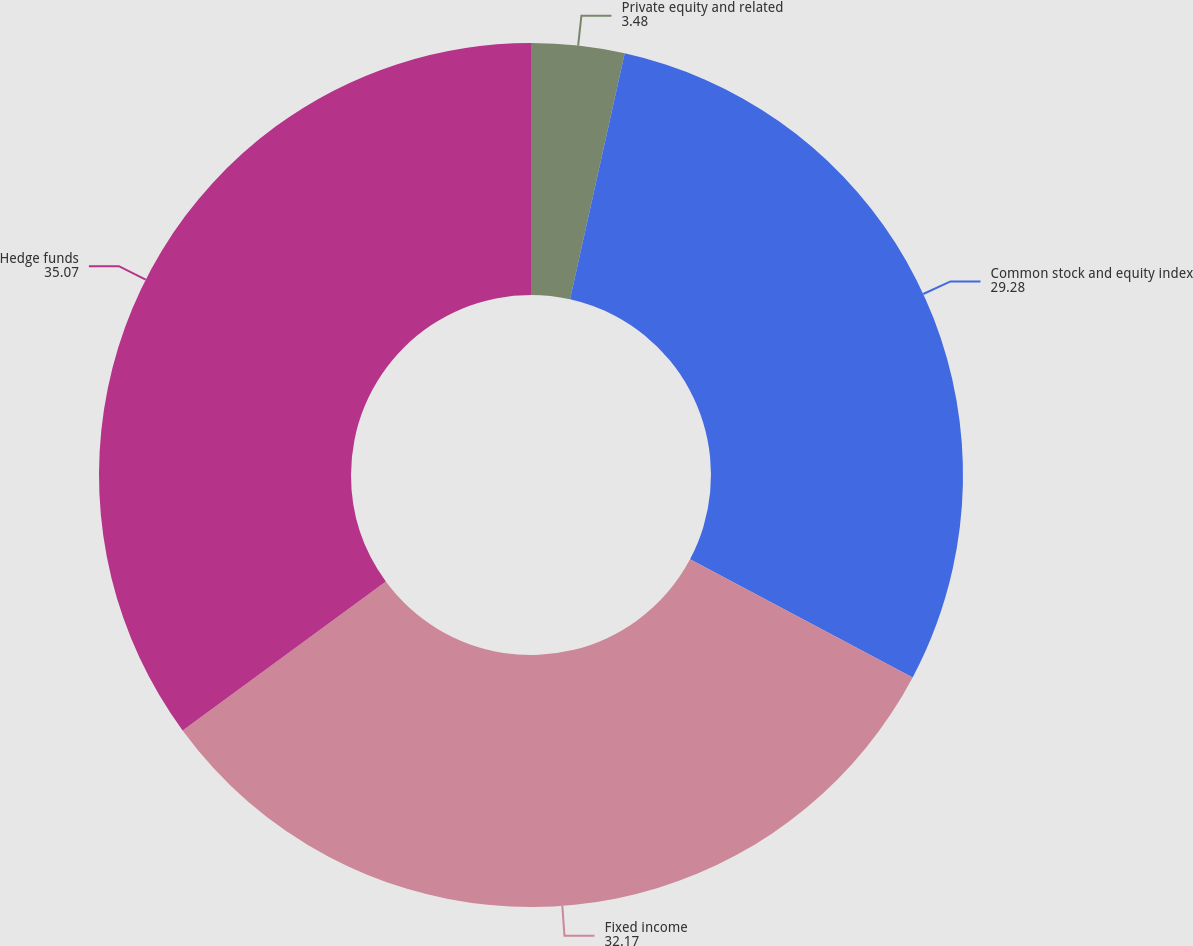Convert chart to OTSL. <chart><loc_0><loc_0><loc_500><loc_500><pie_chart><fcel>Private equity and related<fcel>Common stock and equity index<fcel>Fixed income<fcel>Hedge funds<nl><fcel>3.48%<fcel>29.28%<fcel>32.17%<fcel>35.07%<nl></chart> 